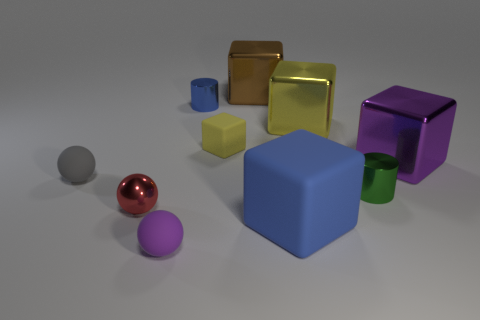Subtract all purple balls. How many balls are left? 2 Subtract all red balls. How many balls are left? 2 Subtract 2 cylinders. How many cylinders are left? 0 Subtract all balls. How many objects are left? 7 Add 2 metallic blocks. How many metallic blocks are left? 5 Add 5 tiny metallic blocks. How many tiny metallic blocks exist? 5 Subtract 1 yellow cubes. How many objects are left? 9 Subtract all green blocks. Subtract all blue cylinders. How many blocks are left? 5 Subtract all gray spheres. How many green cylinders are left? 1 Subtract all large shiny cylinders. Subtract all big metal blocks. How many objects are left? 7 